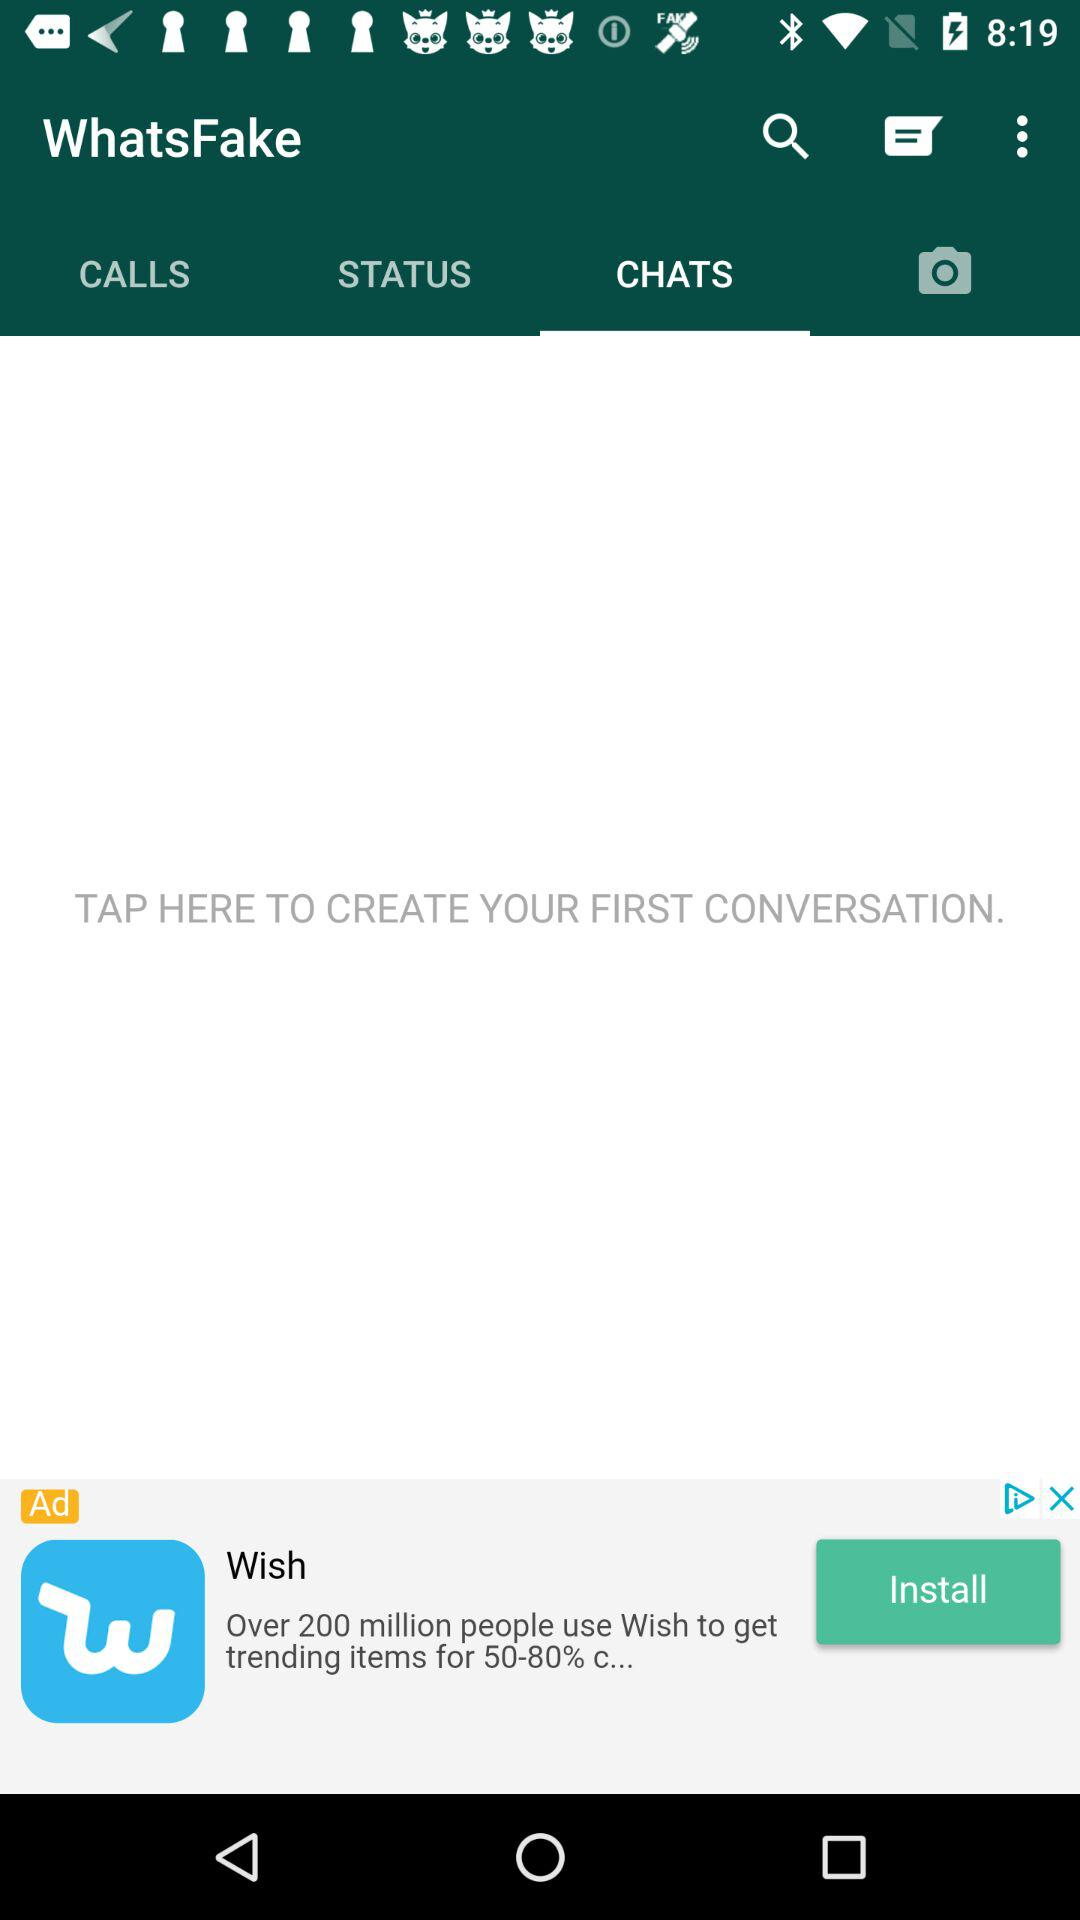Which tab is selected? The selected tab is "CHATS". 